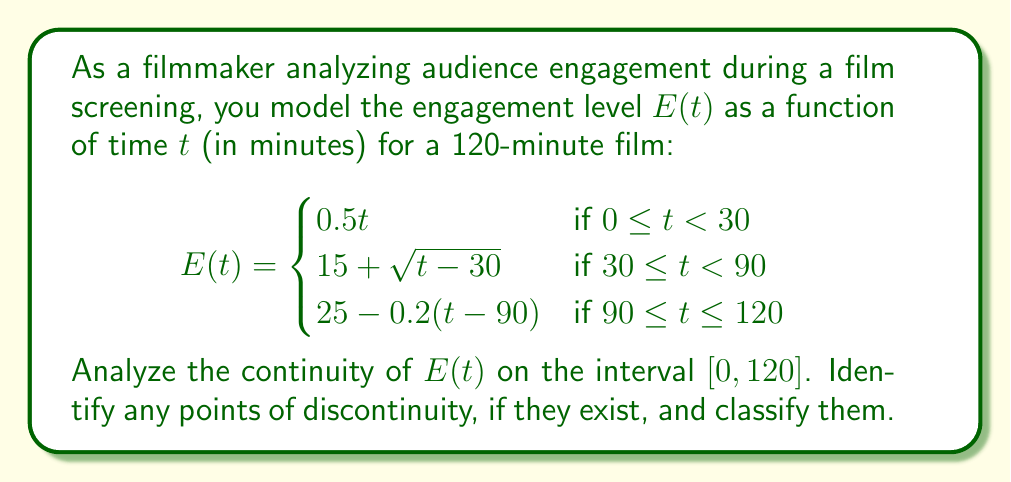Can you solve this math problem? To analyze the continuity of $E(t)$, we need to check for continuity at each piecewise boundary and within each piece:

1. Continuity within each piece:
   Each piece is composed of elementary functions (linear, square root) which are continuous on their respective domains.

2. Continuity at $t = 30$:
   Left limit: $\lim_{t \to 30^-} E(t) = 0.5(30) = 15$
   Right limit: $\lim_{t \to 30^+} E(t) = 15 + \sqrt{30-30} = 15$
   Function value: $E(30) = 15 + \sqrt{0} = 15$
   All three values are equal, so $E(t)$ is continuous at $t = 30$.

3. Continuity at $t = 90$:
   Left limit: $\lim_{t \to 90^-} E(t) = 15 + \sqrt{60} = 15 + \sqrt{60} \approx 22.75$
   Right limit: $\lim_{t \to 90^+} E(t) = 25 - 0.2(90-90) = 25$
   Function value: $E(90) = 15 + \sqrt{60} \approx 22.75$
   
   The left limit and function value are equal, but the right limit is different. This indicates a jump discontinuity at $t = 90$.

4. Continuity at endpoints:
   $E(t)$ is defined at both $t = 0$ and $t = 120$, and the limits from within the interval exist and are equal to the function values.

Therefore, $E(t)$ is continuous on $[0, 90)$ and $(90, 120]$, but has a jump discontinuity at $t = 90$.
Answer: $E(t)$ is continuous on $[0, 90)$ and $(90, 120]$, with a jump discontinuity at $t = 90$. 